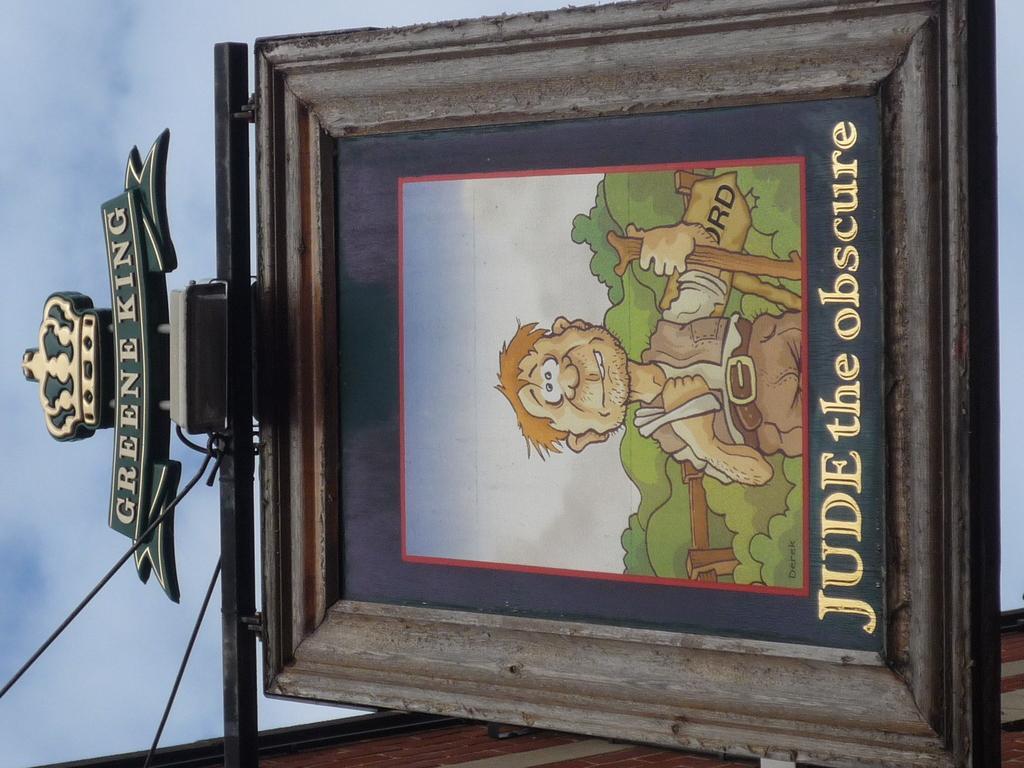Describe this image in one or two sentences. In this image there is the sky, there is a building towards the bottom of the image, there are wires, there is a wooden board, there is a painting on the board, there is text on the board, there is a man holding an object, there are trees. 